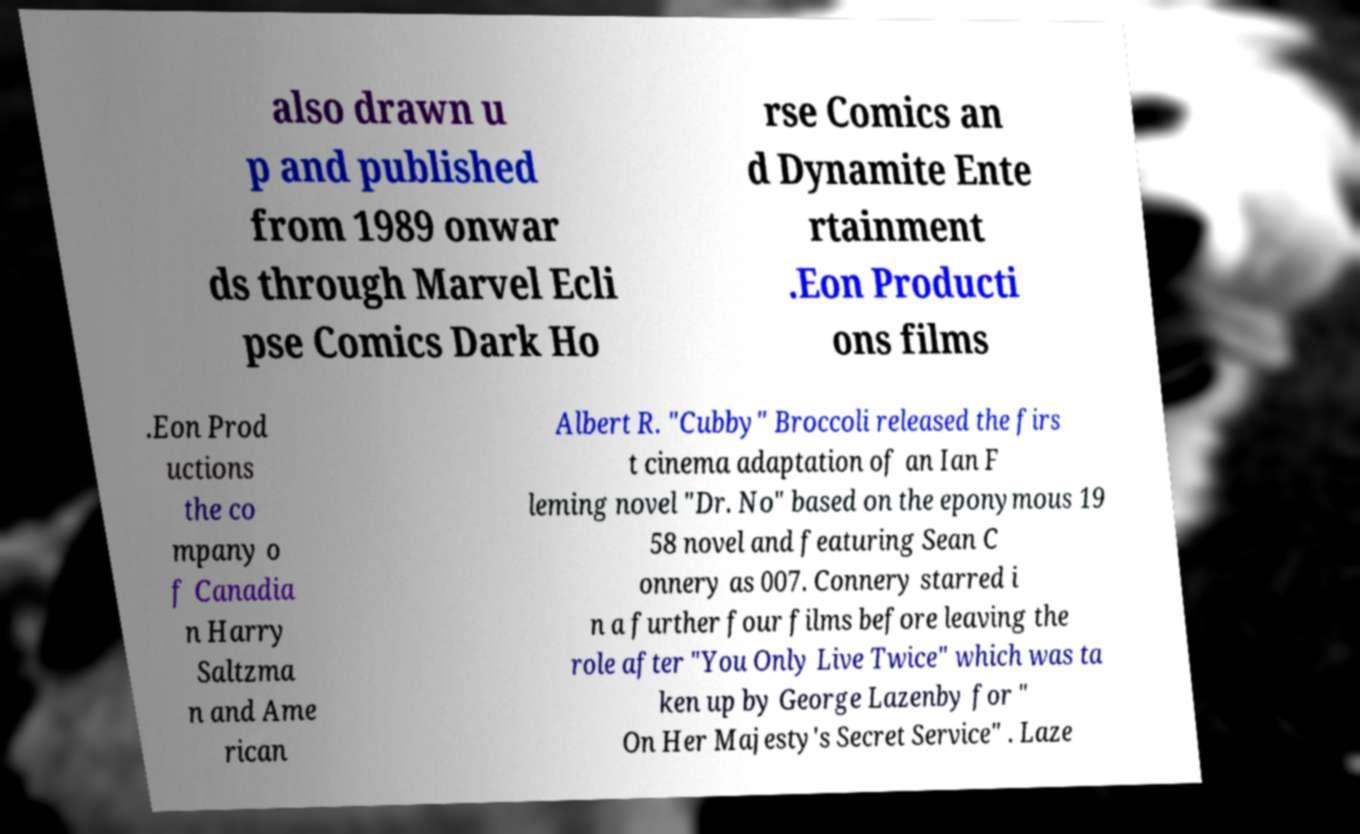Can you read and provide the text displayed in the image?This photo seems to have some interesting text. Can you extract and type it out for me? also drawn u p and published from 1989 onwar ds through Marvel Ecli pse Comics Dark Ho rse Comics an d Dynamite Ente rtainment .Eon Producti ons films .Eon Prod uctions the co mpany o f Canadia n Harry Saltzma n and Ame rican Albert R. "Cubby" Broccoli released the firs t cinema adaptation of an Ian F leming novel "Dr. No" based on the eponymous 19 58 novel and featuring Sean C onnery as 007. Connery starred i n a further four films before leaving the role after "You Only Live Twice" which was ta ken up by George Lazenby for " On Her Majesty's Secret Service" . Laze 